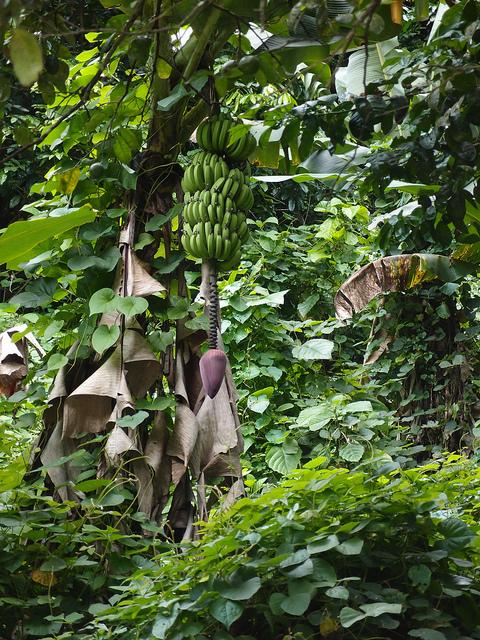Are the bananas ripe?
Concise answer only. No. How many bananas are hanging from the tree?
Quick response, please. 56. What natural environment is this?
Be succinct. Jungle. 